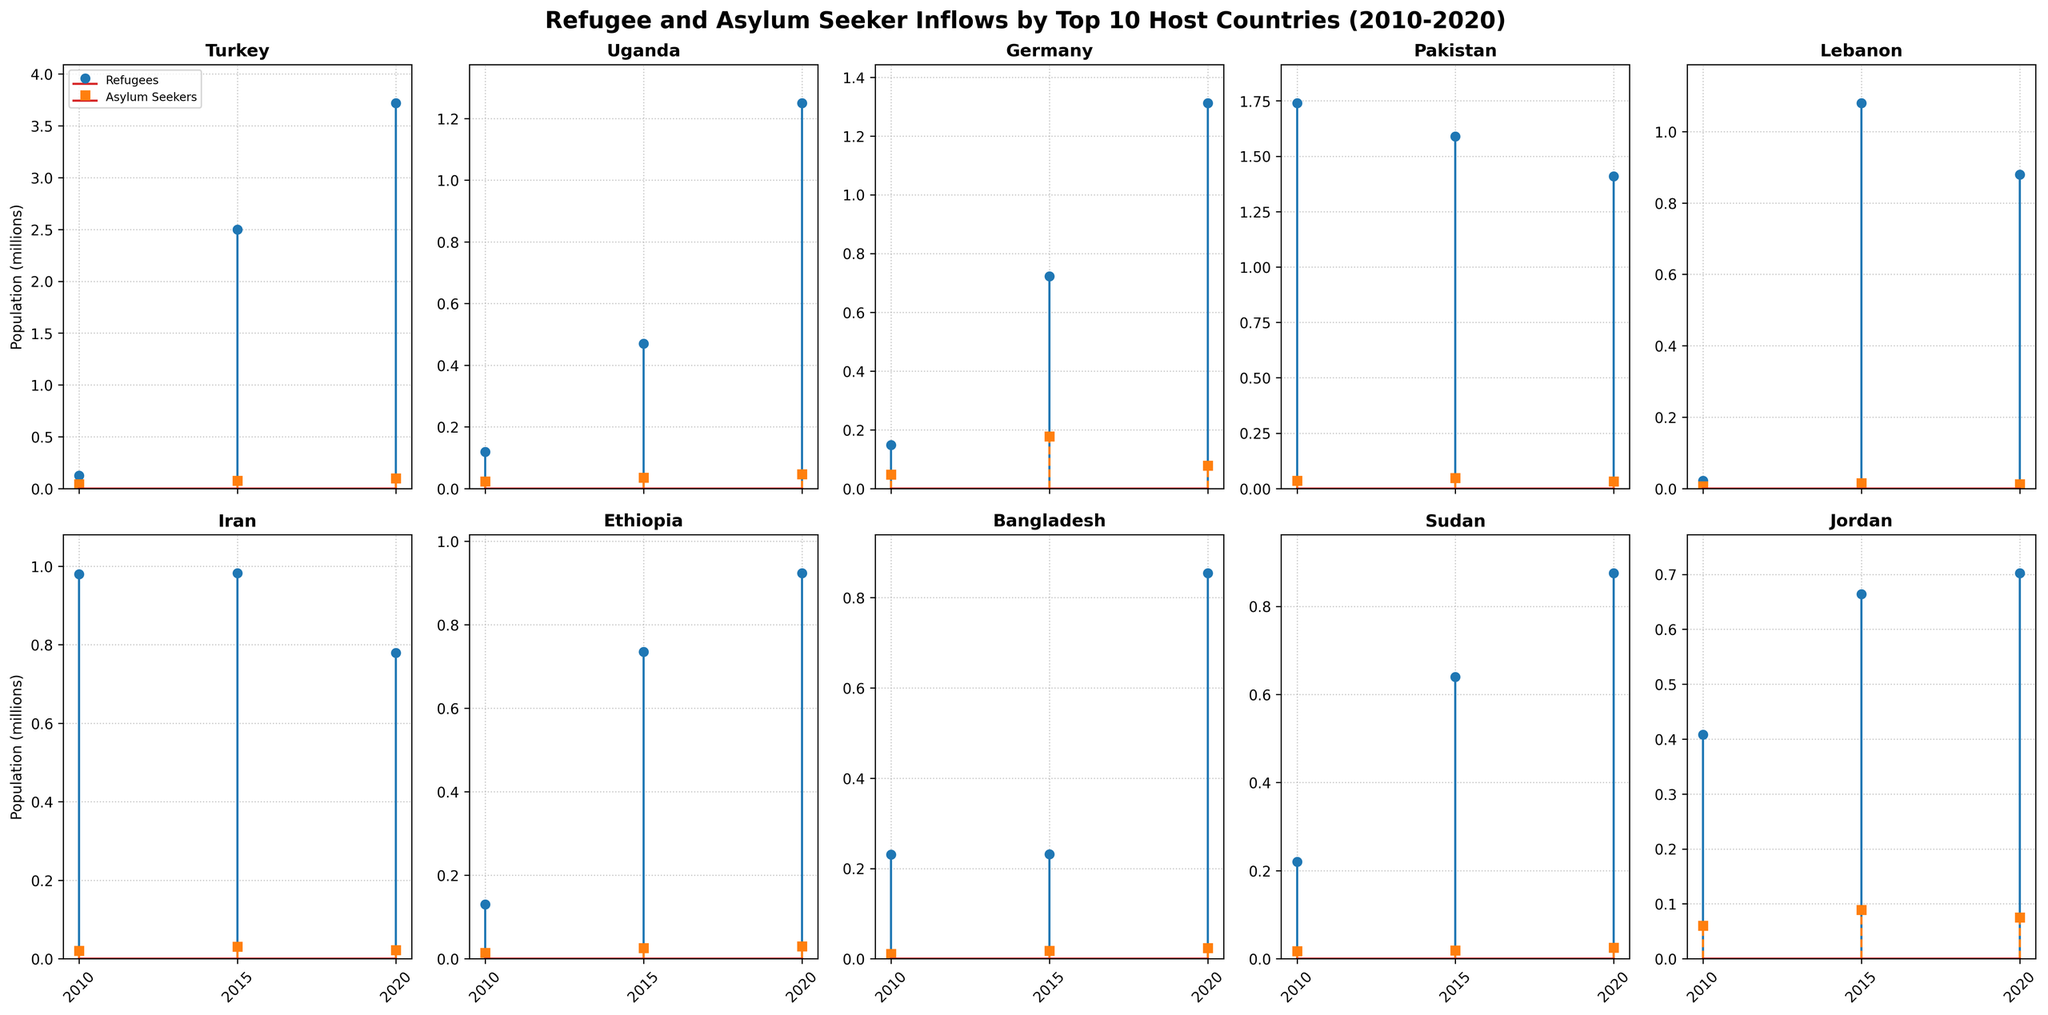What's the overall trend of refugee inflows in Turkey from 2010 to 2020? The plot shows the data points for Turkey in three years: 2010, 2015, and 2020. Observing the blue stems (representing refugees), the numbers increase significantly from 2010 to 2015 and continue to rise in 2020, although not as drastically. This shows an overall increasing trend in refugee inflows in Turkey.
Answer: Increasing Which country had the highest refugee population in 2010? By observing the blue stems (refugees) for each subplot corresponding to the year 2010, Pakistan shows the highest refugee population compared to the other countries.
Answer: Pakistan What changes are observed in the number of asylum seekers in Germany between 2015 and 2020? Looking at the red stems (asylum seekers) for Germany, there is a notable decrease from 177,000 in 2015 to 78,000 in 2020. This indicates a decline in asylum seekers over those periods.
Answer: Decrease Compare the refugee and asylum seeker populations in Uganda in 2010. Which category was higher? For Uganda in 2010, comparing the heights of the blue (refugees) and red (asylum seekers) stems, the refugee population (119,000) is significantly higher than the asylum seeker population (23,000).
Answer: Refugees Which country shows a substantial drop in refugee population from 2015 to 2020? By comparing the lengths of the blue stems for each country in 2015 and 2020, Iran demonstrates a substantial drop from 982,000 refugees in 2015 to 779,000 in 2020.
Answer: Iran How did the refugee population in Ethiopia change from 2010 to 2020? Observing the blue stems for Ethiopia, there is an increase in the refugee population from 130,000 in 2010 to 735,000 in 2015, and then to 923,000 in 2020, indicating a consistent rise.
Answer: Increase Which two countries had similar asylum seeker populations in 2020? By looking at the red stems for 2020, Jordan and Germany had similar asylum seeker populations, both around 75,000 to 78,000.
Answer: Jordan and Germany What is the range of refugee populations in Lebanon from 2010 to 2020? The blue stems for Lebanon indicate the refugee populations as 22,000 in 2010, 1,080,000 in 2015, and 880,000 in 2020. The range is calculated by subtracting the smallest value from the largest value (1,080,000 - 22,000 = 1,058,000).
Answer: 1,058,000 